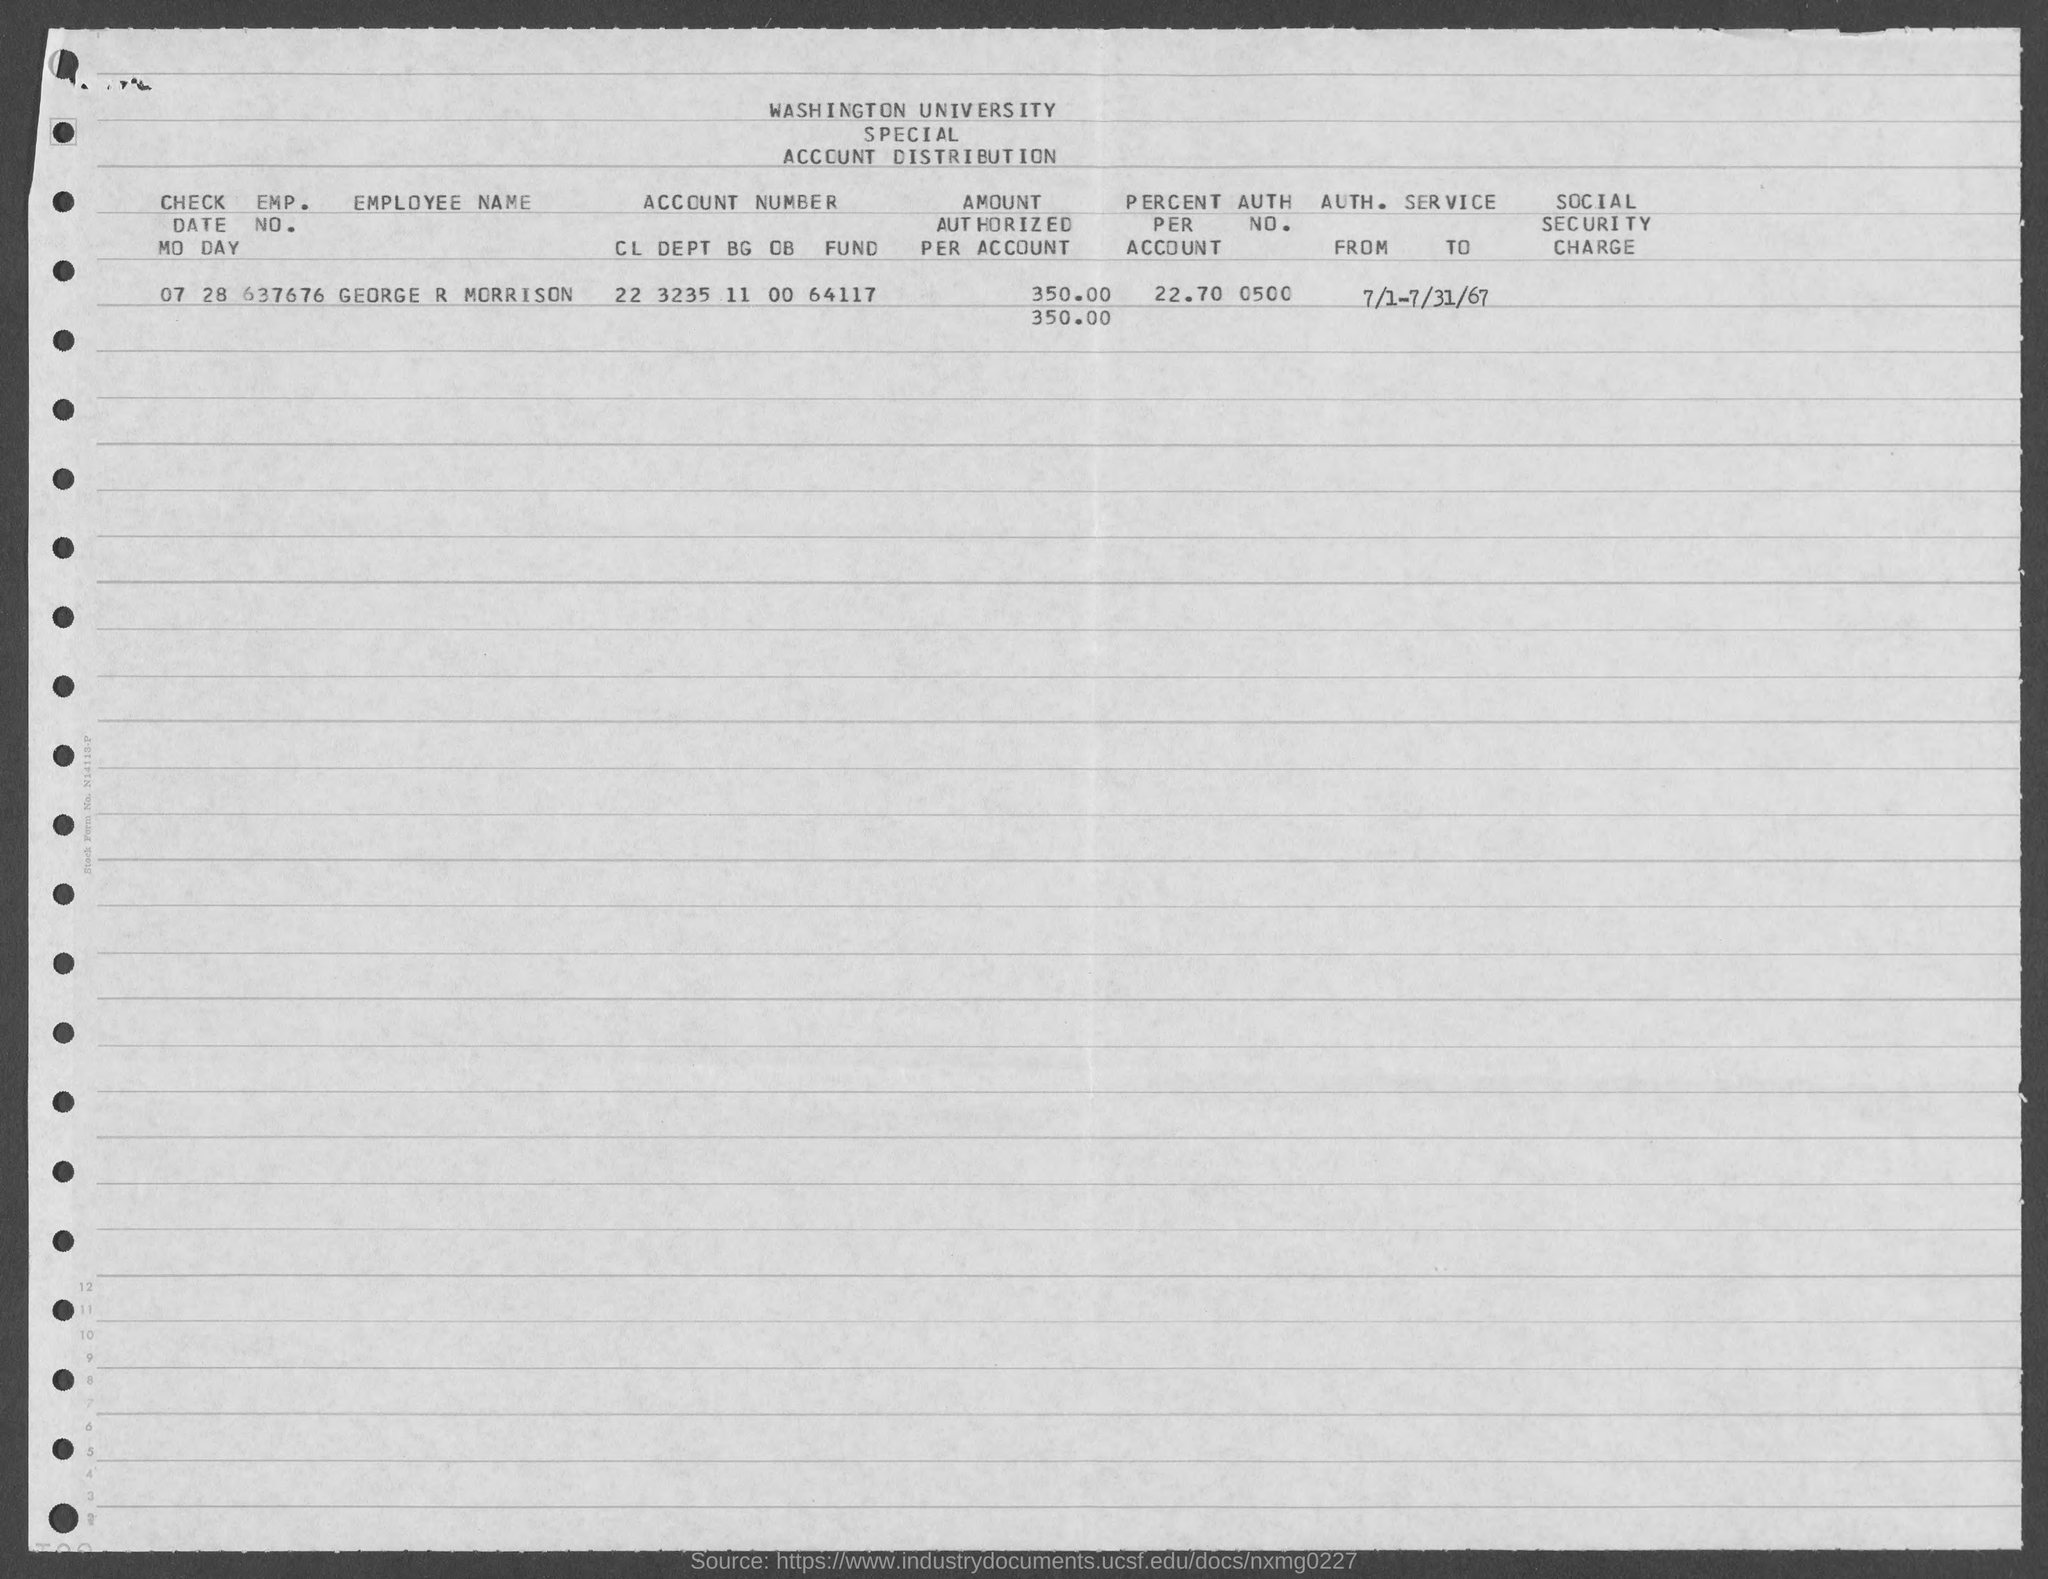What is the emp. no. of george r morrison ?
Offer a terse response. 637676. What is the auth. no. mentioned in the given form ?
Make the answer very short. 0500. What is the value of percent per account as mentioned in the given form ?
Provide a succinct answer. 22.70. What is the employee name mentioned in the given form ?
Keep it short and to the point. George r morrison. What is the check date mentioned in the given form ?
Offer a very short reply. 07 28. 